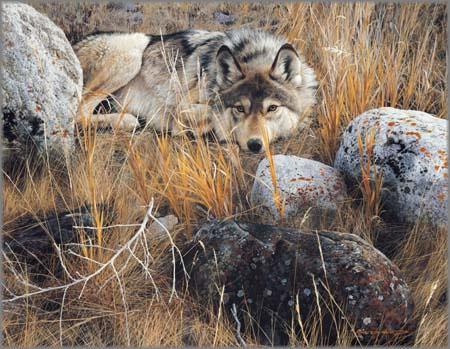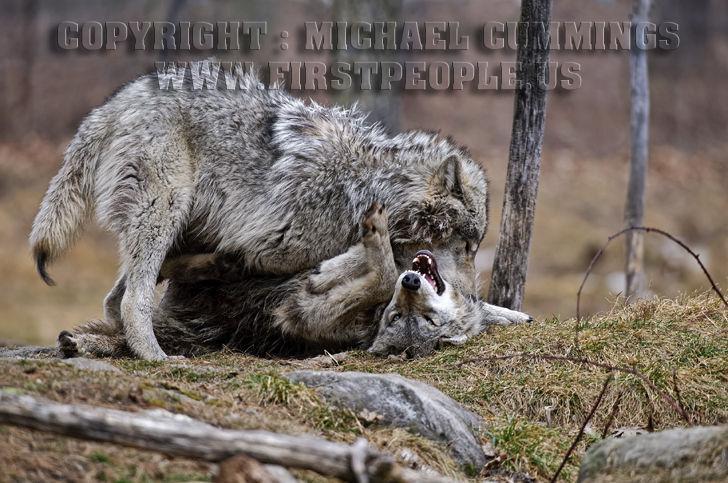The first image is the image on the left, the second image is the image on the right. Analyze the images presented: Is the assertion "One wolf's teeth are visible." valid? Answer yes or no. Yes. The first image is the image on the left, the second image is the image on the right. Examine the images to the left and right. Is the description "Both wolves are lying down and one is laying it's head on it's legs." accurate? Answer yes or no. No. 